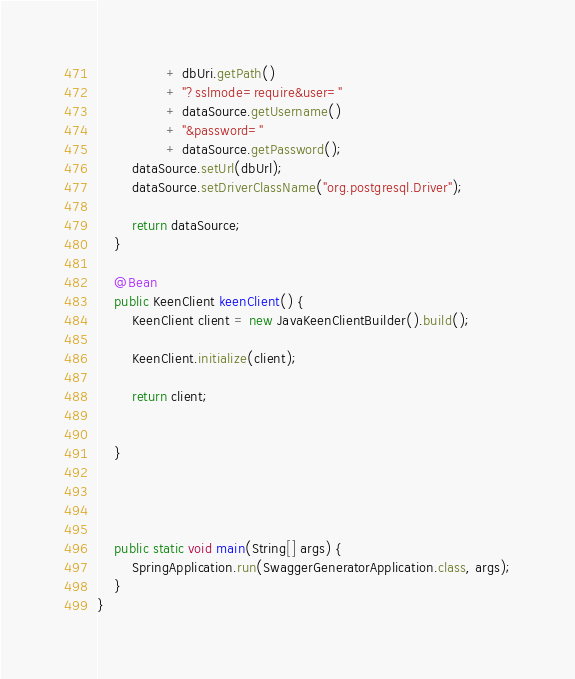<code> <loc_0><loc_0><loc_500><loc_500><_Java_>				+ dbUri.getPath()
				+ "?sslmode=require&user="
				+ dataSource.getUsername()
				+ "&password="
				+ dataSource.getPassword();
		dataSource.setUrl(dbUrl);
		dataSource.setDriverClassName("org.postgresql.Driver");

		return dataSource;
	}

	@Bean
	public KeenClient keenClient() {
		KeenClient client = new JavaKeenClientBuilder().build();

		KeenClient.initialize(client);

		return client;


	}




	public static void main(String[] args) {
		SpringApplication.run(SwaggerGeneratorApplication.class, args);
	}
}
</code> 